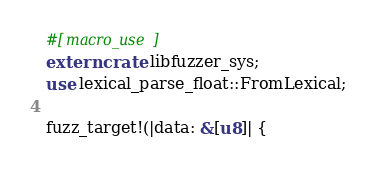Convert code to text. <code><loc_0><loc_0><loc_500><loc_500><_Rust_>#[macro_use]
extern crate libfuzzer_sys;
use lexical_parse_float::FromLexical;

fuzz_target!(|data: &[u8]| {</code> 